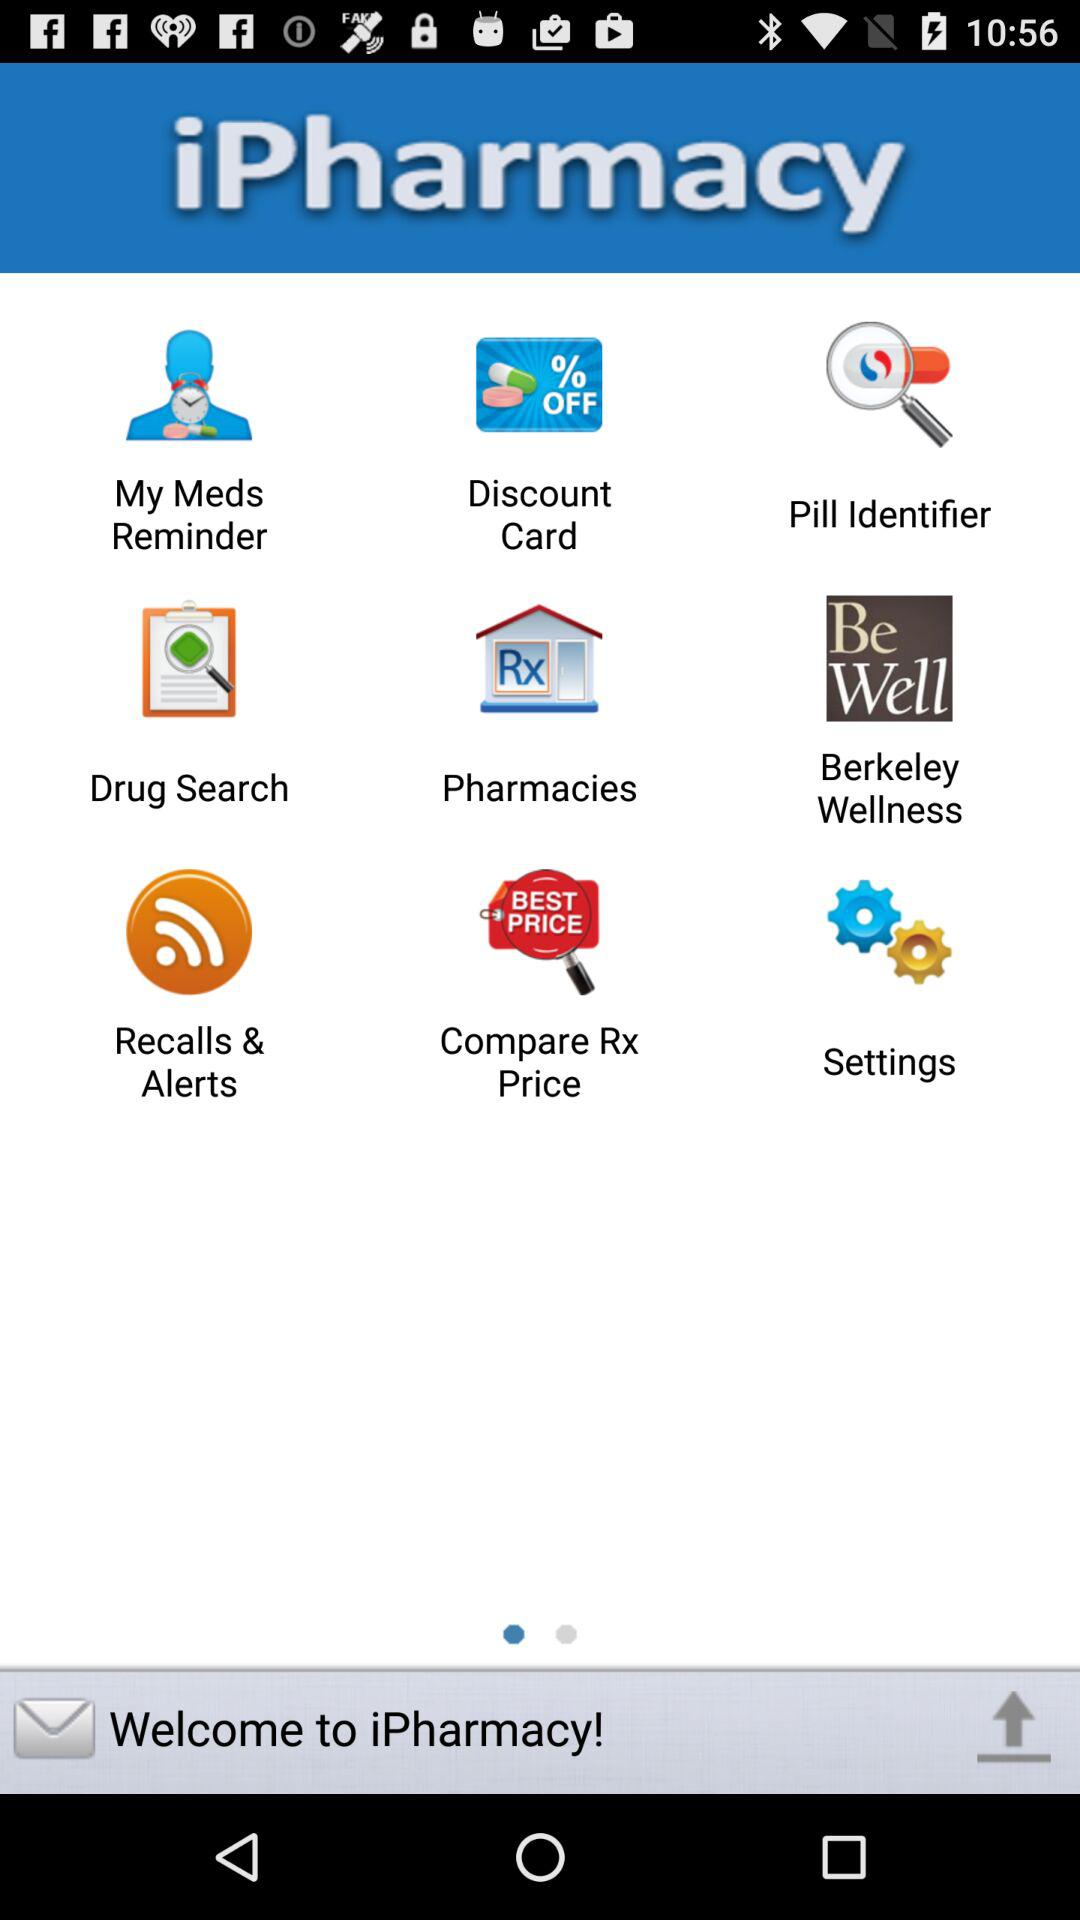What is the name of the application? The name of the application is "iPharmacy". 